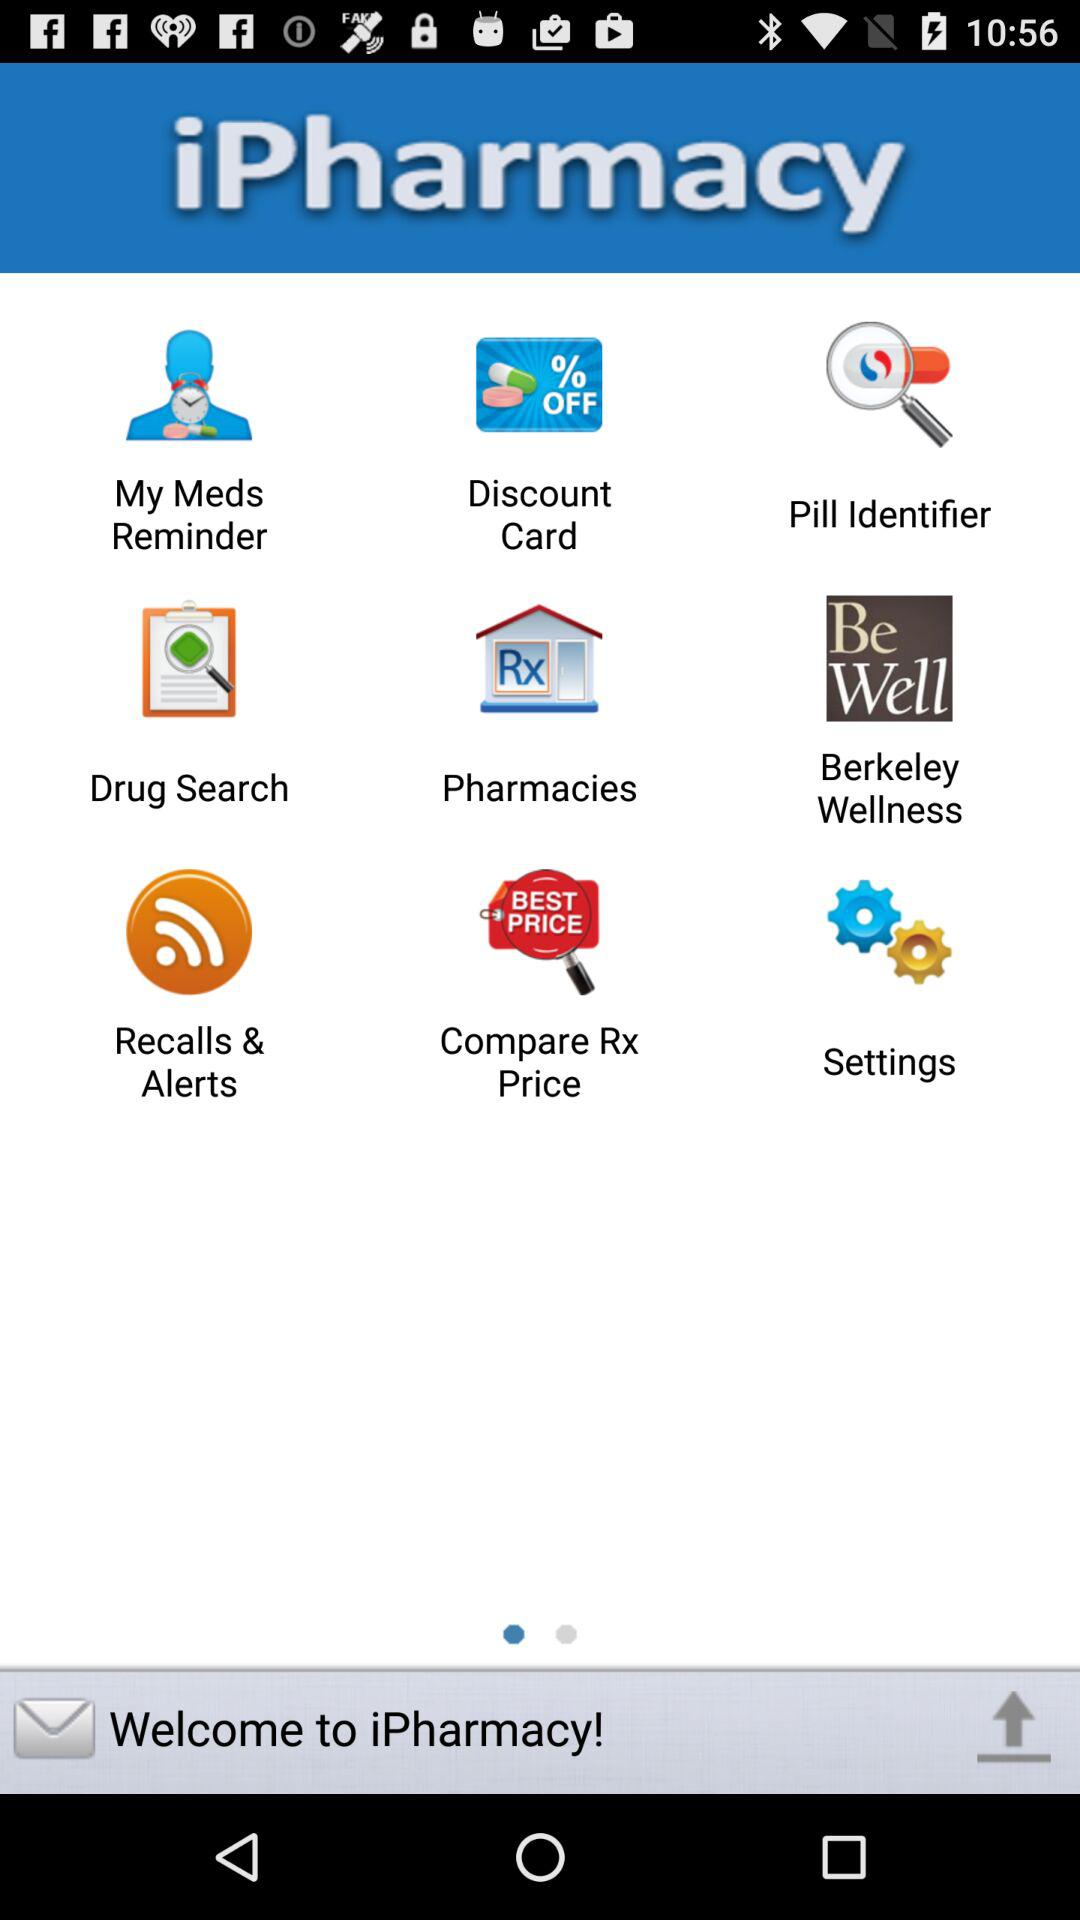What is the name of the application? The name of the application is "iPharmacy". 